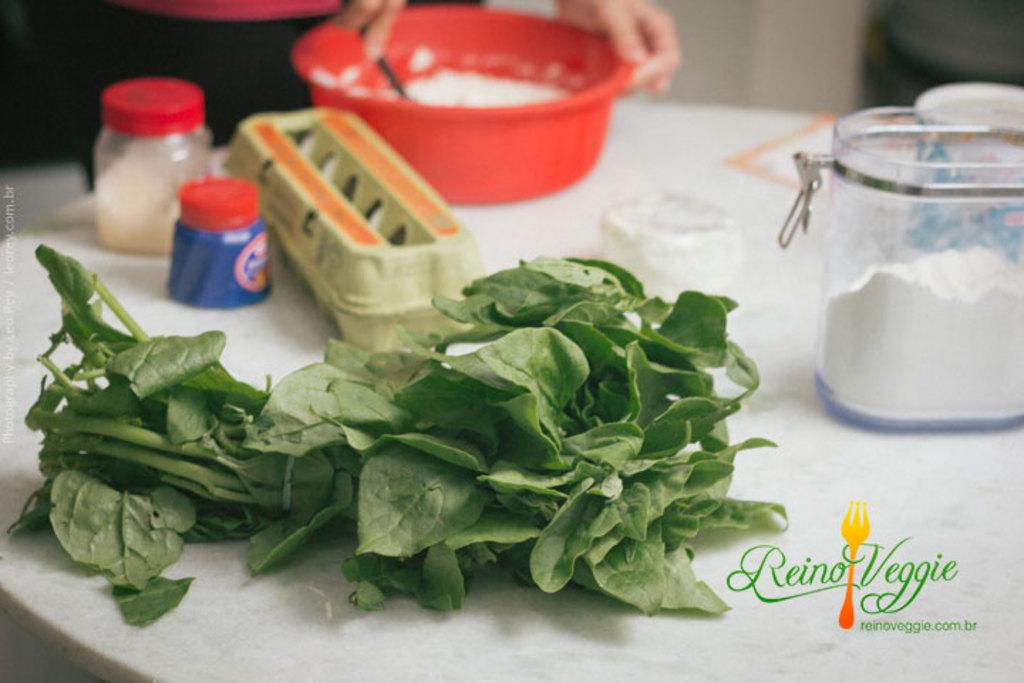What type of food item is on the table in the image? There is a leafy vegetable on the table. What else can be seen on the table besides the vegetable? There are small bottles and an egg tray on the table. What is used for seasoning in the image? There is a salt bottle on the table. What songs are being sung by the window in the image? There is no mention of songs or a window in the image; it only features a leafy vegetable, small bottles, an egg tray, and a salt bottle on the table. 